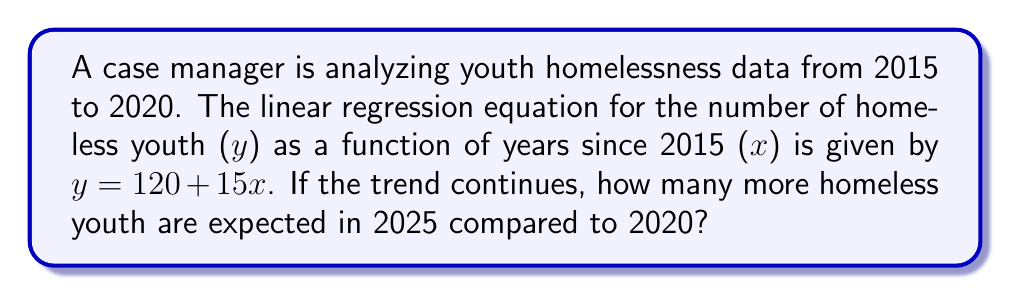Can you answer this question? 1) First, we need to understand what the equation $y = 120 + 15x$ represents:
   - y is the number of homeless youth
   - x is the number of years since 2015
   - 120 is the initial number of homeless youth in 2015
   - 15 is the annual increase in homeless youth

2) To find the number of homeless youth in 2020:
   - 2020 is 5 years after 2015, so x = 5
   - $y = 120 + 15(5) = 120 + 75 = 195$

3) To find the number of homeless youth in 2025:
   - 2025 is 10 years after 2015, so x = 10
   - $y = 120 + 15(10) = 120 + 150 = 270$

4) To find the difference between 2025 and 2020:
   $270 - 195 = 75$

Therefore, if the trend continues, there will be 75 more homeless youth in 2025 compared to 2020.
Answer: 75 